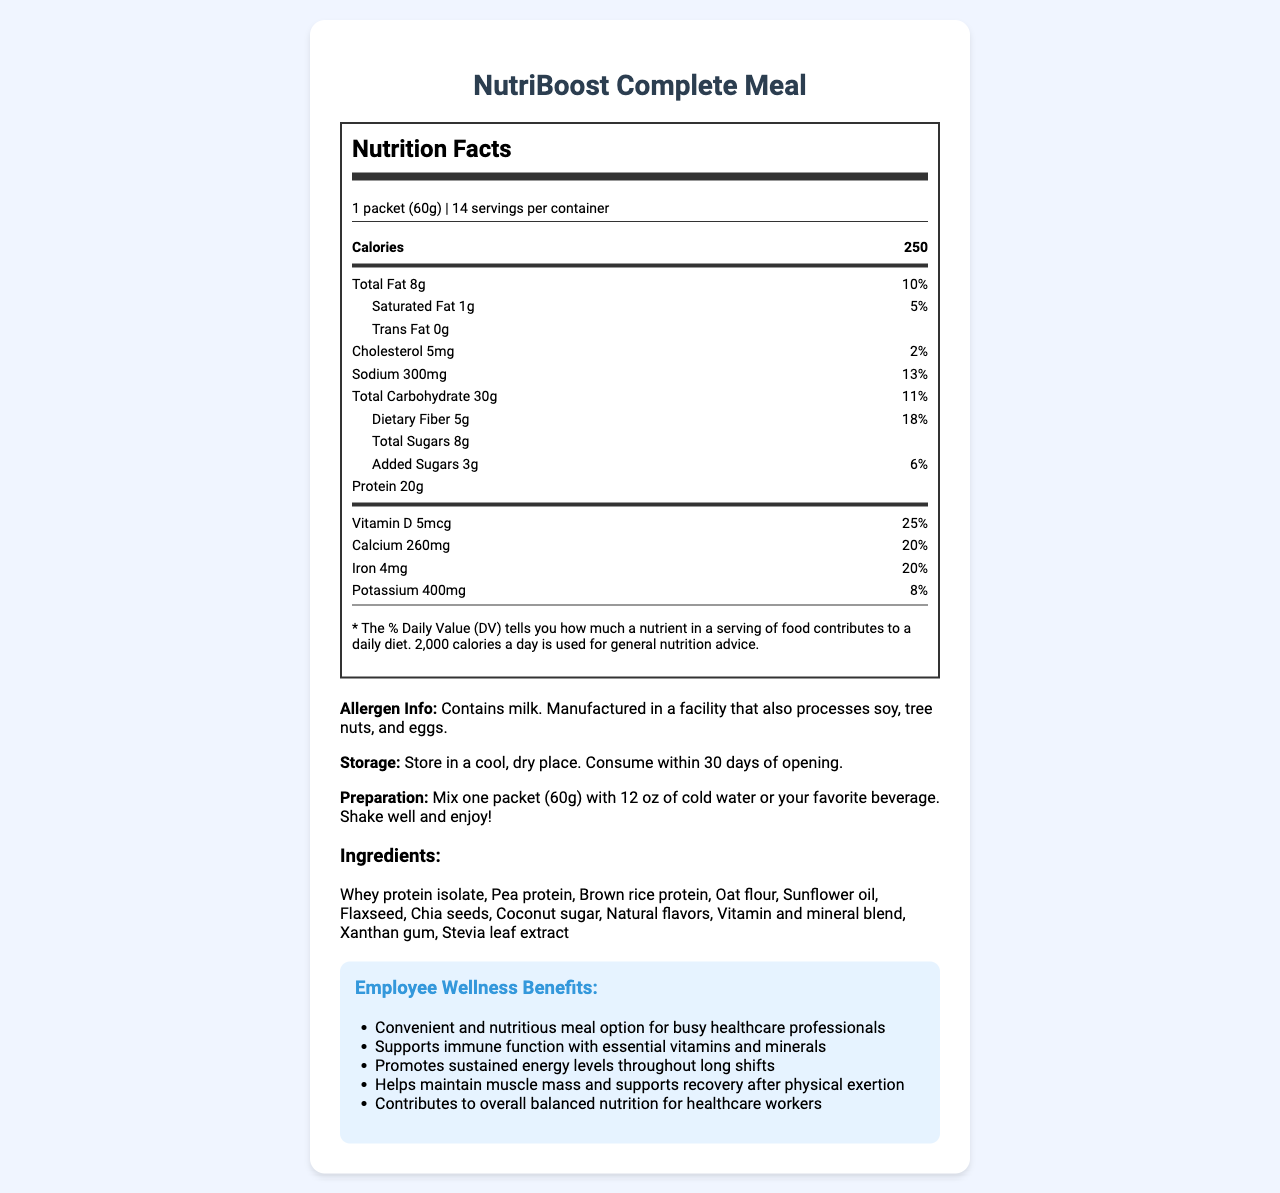What is the serving size of NutriBoost Complete Meal? The serving size is listed in the document as "1 packet (60g)".
Answer: 1 packet (60g) How many servings are there per container? The document states that there are 14 servings per container.
Answer: 14 What is the total fat content per serving? The total fat content is listed as "8g".
Answer: 8g What is the cholesterol content per serving? The cholesterol content is listed as "5mg".
Answer: 5mg How much protein is in one serving of NutriBoost Complete Meal? The protein content is given as "20g".
Answer: 20g How many calories are there per serving in NutriBoost Complete Meal? A. 200 B. 250 C. 300 D. 350 The document specifies that there are 250 calories per serving.
Answer: B What percentage of Daily Value (% DV) does Vitamin D provide? A. 15% B. 20% C. 25% D. 30% Vitamin D provides 25% of the Daily Value (% DV), as listed in the document.
Answer: C Is this product suitable for someone with a milk allergy? The allergen information states that the product contains milk, making it unsuitable for someone with a milk allergy.
Answer: No What are some potential employee wellness benefits mentioned for NutriBoost Complete Meal? These benefits are listed under the "Employee Wellness Benefits" section in the document.
Answer: Convenient and nutritious meal option for busy healthcare professionals; Supports immune function with essential vitamins and minerals; Promotes sustained energy levels throughout long shifts; Helps maintain muscle mass and supports recovery after physical exertion; Contributes to overall balanced nutrition for healthcare workers Describe the main idea of the document. The document is a detailed nutrition label and informational guide for a nutrient-dense meal replacement product, highlighting its health benefits and suitability for healthcare professionals.
Answer: The document provides the Nutrition Facts Label and additional details for NutriBoost Complete Meal, outlining its serving size, nutritional content, ingredients, allergen information, storage/preparation instructions, and potential employee wellness benefits. What is the main protein source in NutriBoost Complete Meal? The first ingredient listed is "Whey protein isolate", which indicates that it is the main protein source.
Answer: Whey protein isolate What is the added sugars content per serving? The document indicates that the added sugars content is "3g".
Answer: 3g Is there any trans fat present in NutriBoost Complete Meal? The document states that the trans fat content is "0g".
Answer: No What is the recommended storage instruction for NutriBoost Complete Meal? The storage instructions are provided in a specific section in the document.
Answer: Store in a cool, dry place. Consume within 30 days of opening. What is the total daily value percentage of Iron provided by one serving? The daily value percentage for Iron is listed as "20%" in the document.
Answer: 20% How should NutriBoost Complete Meal be prepared? The preparation instructions provided in the document give this detailed guideline.
Answer: Mix one packet (60g) with 12 oz of cold water or your favorite beverage. Shake well and enjoy! Does the document provide information on dietary restrictions? The allergen information section states: "Contains milk. Manufactured in a facility that also processes soy, tree nuts, and eggs." and indicates dietary considerations.
Answer: Yes What is the main purpose of NutriBoost Complete Meal in terms of employee wellness? The summary of wellness benefits section details the main purposes clearly.
Answer: It provides a convenient and nutritious meal option that supports immune function, promotes sustained energy levels, helps maintain muscle mass, supports recovery, and contributes to balanced nutrition for healthcare workers. How much Vitamin B12 is in NutriBoost Complete Meal? The document lists the amount of Vitamin B12 as "2mcg".
Answer: 2mcg Which vitamin provides the highest percentage of Daily Value per serving? A. Vitamin A B. Vitamin B12 C. Vitamin C D. Biotin Biotin provides the highest percentage of Daily Value at 500%.
Answer: D How much sugar is included in a serving of NutriBoost Complete Meal? The document specifies that the total sugar content is "8g".
Answer: 8g What is the total carbohydrate content per serving? The total carbohydrate content is listed as "30g".
Answer: 30g Does NutriBoost Complete Meal contain soy? The document states it is manufactured in a facility that also processes soy, but it does not indicate whether soy is a listed ingredient.
Answer: Cannot be determined 